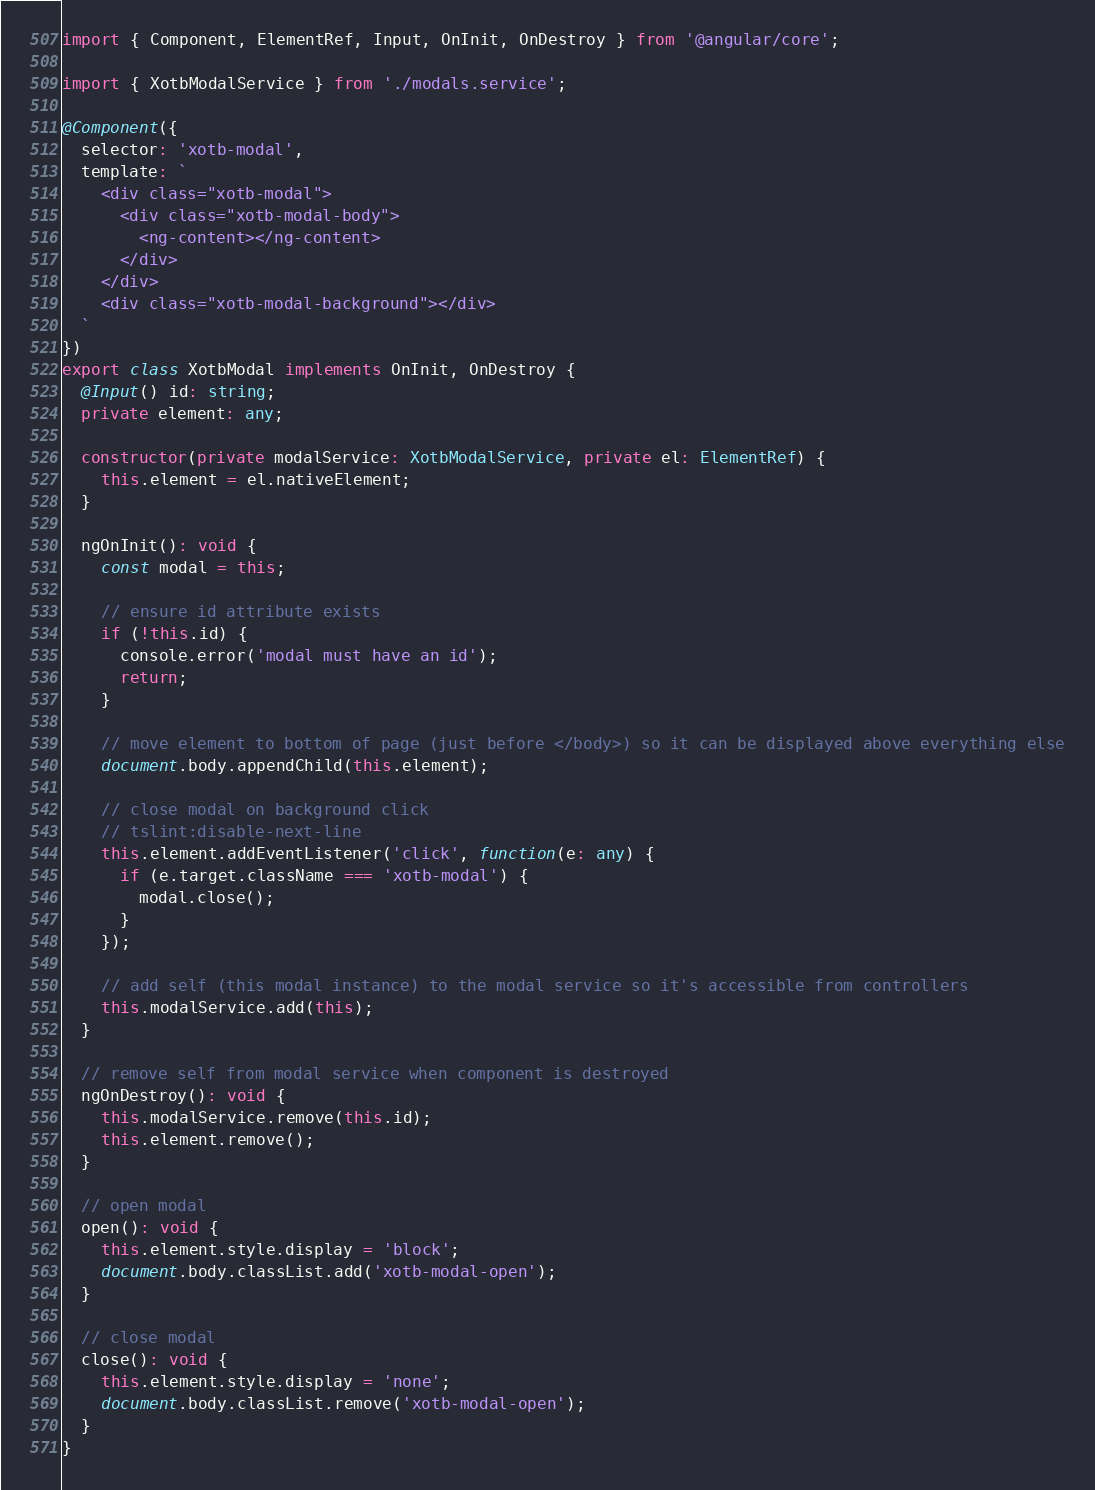Convert code to text. <code><loc_0><loc_0><loc_500><loc_500><_TypeScript_>import { Component, ElementRef, Input, OnInit, OnDestroy } from '@angular/core';

import { XotbModalService } from './modals.service';

@Component({
  selector: 'xotb-modal',
  template: `
    <div class="xotb-modal">
      <div class="xotb-modal-body">
        <ng-content></ng-content>
      </div>
    </div>
    <div class="xotb-modal-background"></div>
  `
})
export class XotbModal implements OnInit, OnDestroy {
  @Input() id: string;
  private element: any;

  constructor(private modalService: XotbModalService, private el: ElementRef) {
    this.element = el.nativeElement;
  }

  ngOnInit(): void {
    const modal = this;

    // ensure id attribute exists
    if (!this.id) {
      console.error('modal must have an id');
      return;
    }

    // move element to bottom of page (just before </body>) so it can be displayed above everything else
    document.body.appendChild(this.element);

    // close modal on background click
    // tslint:disable-next-line
    this.element.addEventListener('click', function(e: any) {
      if (e.target.className === 'xotb-modal') {
        modal.close();
      }
    });

    // add self (this modal instance) to the modal service so it's accessible from controllers
    this.modalService.add(this);
  }

  // remove self from modal service when component is destroyed
  ngOnDestroy(): void {
    this.modalService.remove(this.id);
    this.element.remove();
  }

  // open modal
  open(): void {
    this.element.style.display = 'block';
    document.body.classList.add('xotb-modal-open');
  }

  // close modal
  close(): void {
    this.element.style.display = 'none';
    document.body.classList.remove('xotb-modal-open');
  }
}
</code> 